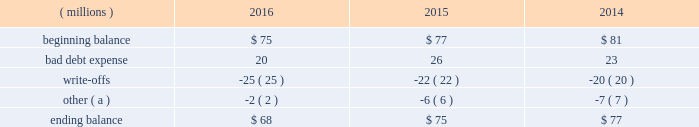Cash and cash equivalents cash equivalents include highly-liquid investments with a maturity of three months or less when purchased .
Accounts receivable and allowance for doubtful accounts accounts receivable are carried at the invoiced amounts , less an allowance for doubtful accounts , and generally do not bear interest .
The company estimates the balance of allowance for doubtful accounts by analyzing accounts receivable balances by age and applying historical write-off and collection trend rates .
The company 2019s estimates include separately providing for customer receivables based on specific circumstances and credit conditions , and when it is deemed probable that the balance is uncollectible .
Account balances are charged off against the allowance when it is determined the receivable will not be recovered .
The company 2019s allowance for doubtful accounts balance also includes an allowance for the expected return of products shipped and credits related to pricing or quantities shipped of $ 14 million , $ 15 million and $ 14 million as of december 31 , 2016 , 2015 , and 2014 , respectively .
Returns and credit activity is recorded directly to sales as a reduction .
The table summarizes the activity in the allowance for doubtful accounts: .
( a ) other amounts are primarily the effects of changes in currency translations and the impact of allowance for returns and credits .
Inventory valuations inventories are valued at the lower of cost or market .
Certain u.s .
Inventory costs are determined on a last-in , first-out ( 201clifo 201d ) basis .
Lifo inventories represented 40% ( 40 % ) and 39% ( 39 % ) of consolidated inventories as of december 31 , 2016 and 2015 , respectively .
Lifo inventories include certain legacy nalco u.s .
Inventory acquired at fair value as part of the nalco merger .
All other inventory costs are determined using either the average cost or first-in , first-out ( 201cfifo 201d ) methods .
Inventory values at fifo , as shown in note 5 , approximate replacement cost .
During 2015 , the company improved and standardized estimates related to its inventory reserves and product costing , resulting in a net pre-tax charge of approximately $ 6 million .
Separately , the actions resulted in a charge of $ 20.6 million related to inventory reserve calculations , partially offset by a gain of $ 14.5 million related to the capitalization of certain cost components into inventory .
During 2016 , the company took additional actions to improve and standardize estimates related to the capitalization of certain cost components into inventory , which resulted in a gain of $ 6.2 million .
These items are reflected within special ( gains ) and charges , as discussed in note 3 .
Property , plant and equipment property , plant and equipment assets are stated at cost .
Merchandising and customer equipment consists principally of various dispensing systems for the company 2019s cleaning and sanitizing products , dishwashing machines and process control and monitoring equipment .
Certain dispensing systems capitalized by the company are accounted for on a mass asset basis , whereby equipment is capitalized and depreciated as a group and written off when fully depreciated .
The company capitalizes both internal and external costs of development or purchase of computer software for internal use .
Costs incurred for data conversion , training and maintenance associated with capitalized software are expensed as incurred .
Expenditures for major renewals and improvements , which significantly extend the useful lives of existing plant and equipment , are capitalized and depreciated .
Expenditures for repairs and maintenance are charged to expense as incurred .
Upon retirement or disposition of plant and equipment , the cost and related accumulated depreciation are removed from the accounts and any resulting gain or loss is recognized in income .
Depreciation is charged to operations using the straight-line method over the assets 2019 estimated useful lives ranging from 5 to 40 years for buildings and leasehold improvements , 3 to 20 years for machinery and equipment , 3 to 15 years for merchandising and customer equipment and 3 to 7 years for capitalized software .
The straight-line method of depreciation reflects an appropriate allocation of the cost of the assets to earnings in proportion to the amount of economic benefits obtained by the company in each reporting period .
Depreciation expense was $ 561 million , $ 560 million and $ 558 million for 2016 , 2015 and 2014 , respectively. .
What is the net change in the balance of allowance for doubtful accounts during 2015? 
Computations: (75 - 77)
Answer: -2.0. 